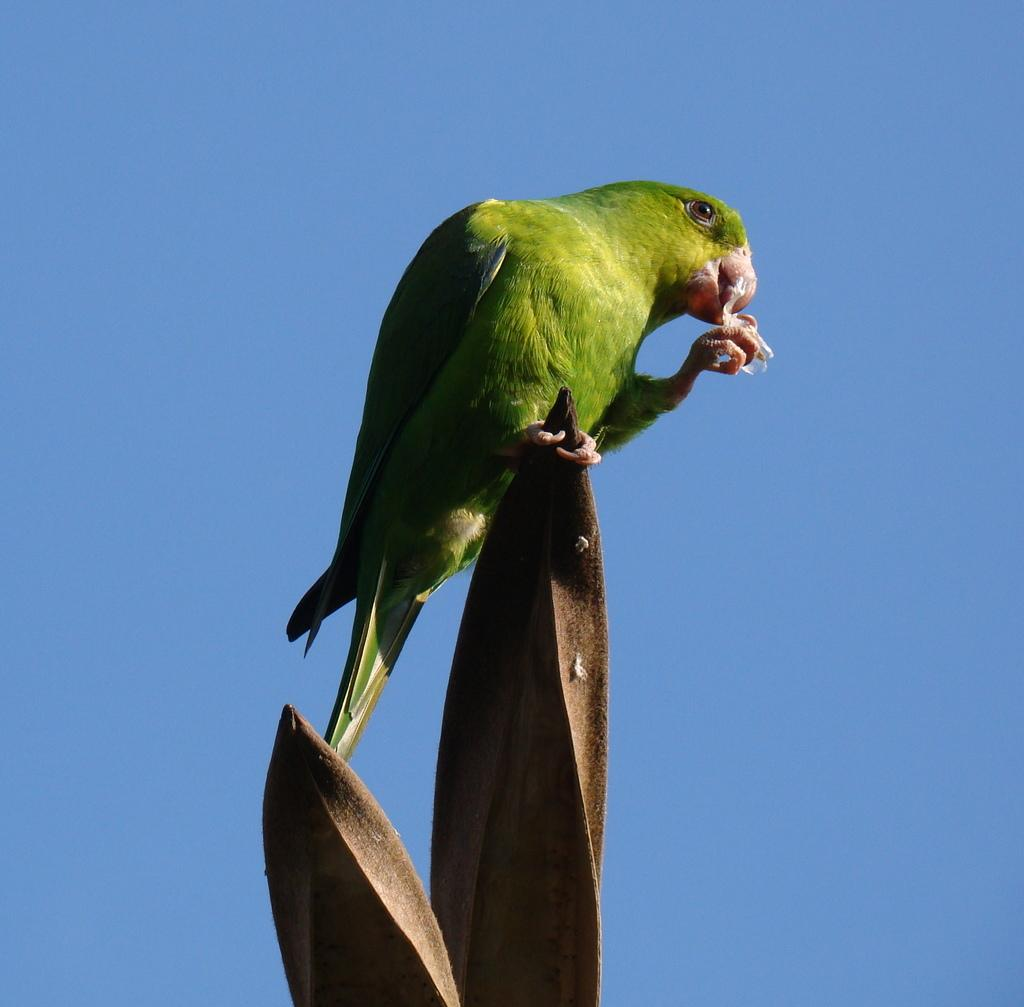What type of animal is in the image? There is a bird in the image. Where is the bird located? The bird is on an object. What can be seen behind the bird? The sky is visible behind the bird. What type of pest is the bird managing in the image? There is no indication in the image that the bird is managing any pests, as the image only shows a bird on an object with the sky visible behind it. 